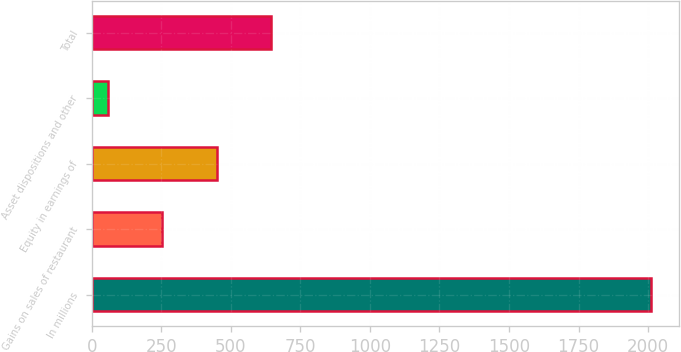<chart> <loc_0><loc_0><loc_500><loc_500><bar_chart><fcel>In millions<fcel>Gains on sales of restaurant<fcel>Equity in earnings of<fcel>Asset dispositions and other<fcel>Total<nl><fcel>2009<fcel>253.82<fcel>448.84<fcel>58.8<fcel>643.86<nl></chart> 